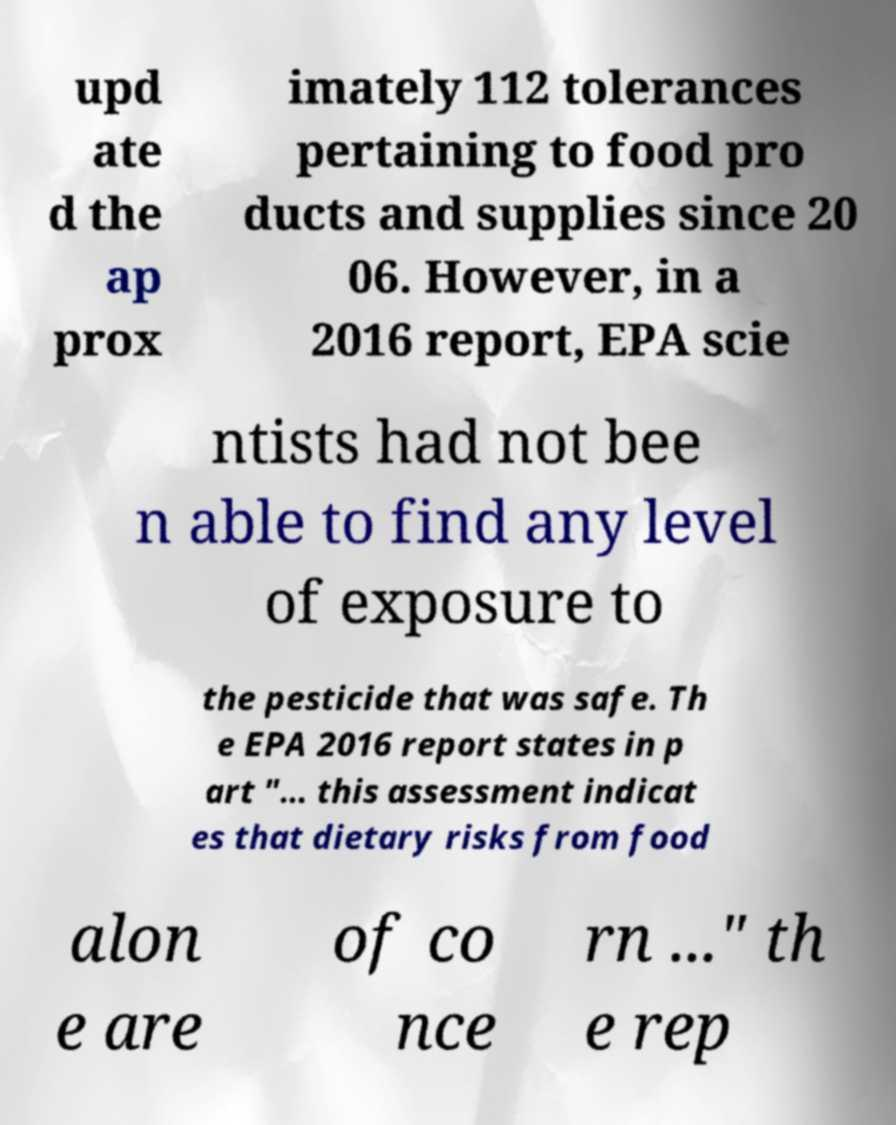Please read and relay the text visible in this image. What does it say? upd ate d the ap prox imately 112 tolerances pertaining to food pro ducts and supplies since 20 06. However, in a 2016 report, EPA scie ntists had not bee n able to find any level of exposure to the pesticide that was safe. Th e EPA 2016 report states in p art "... this assessment indicat es that dietary risks from food alon e are of co nce rn ..." th e rep 